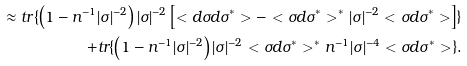<formula> <loc_0><loc_0><loc_500><loc_500>\approx t r \{ \left ( 1 - n ^ { - 1 } | \sigma | ^ { - 2 } \right ) | \sigma | ^ { - 2 } \left [ < d \sigma d \sigma ^ { * } > - < \sigma d \sigma ^ { * } > ^ { * } | \sigma | ^ { - 2 } < \sigma d \sigma ^ { * } > \right ] \} \\ + t r \{ \left ( 1 - n ^ { - 1 } | \sigma | ^ { - 2 } \right ) | \sigma | ^ { - 2 } < \sigma d \sigma ^ { * } > ^ { * } n ^ { - 1 } | \sigma | ^ { - 4 } < \sigma d \sigma ^ { * } > \} .</formula> 